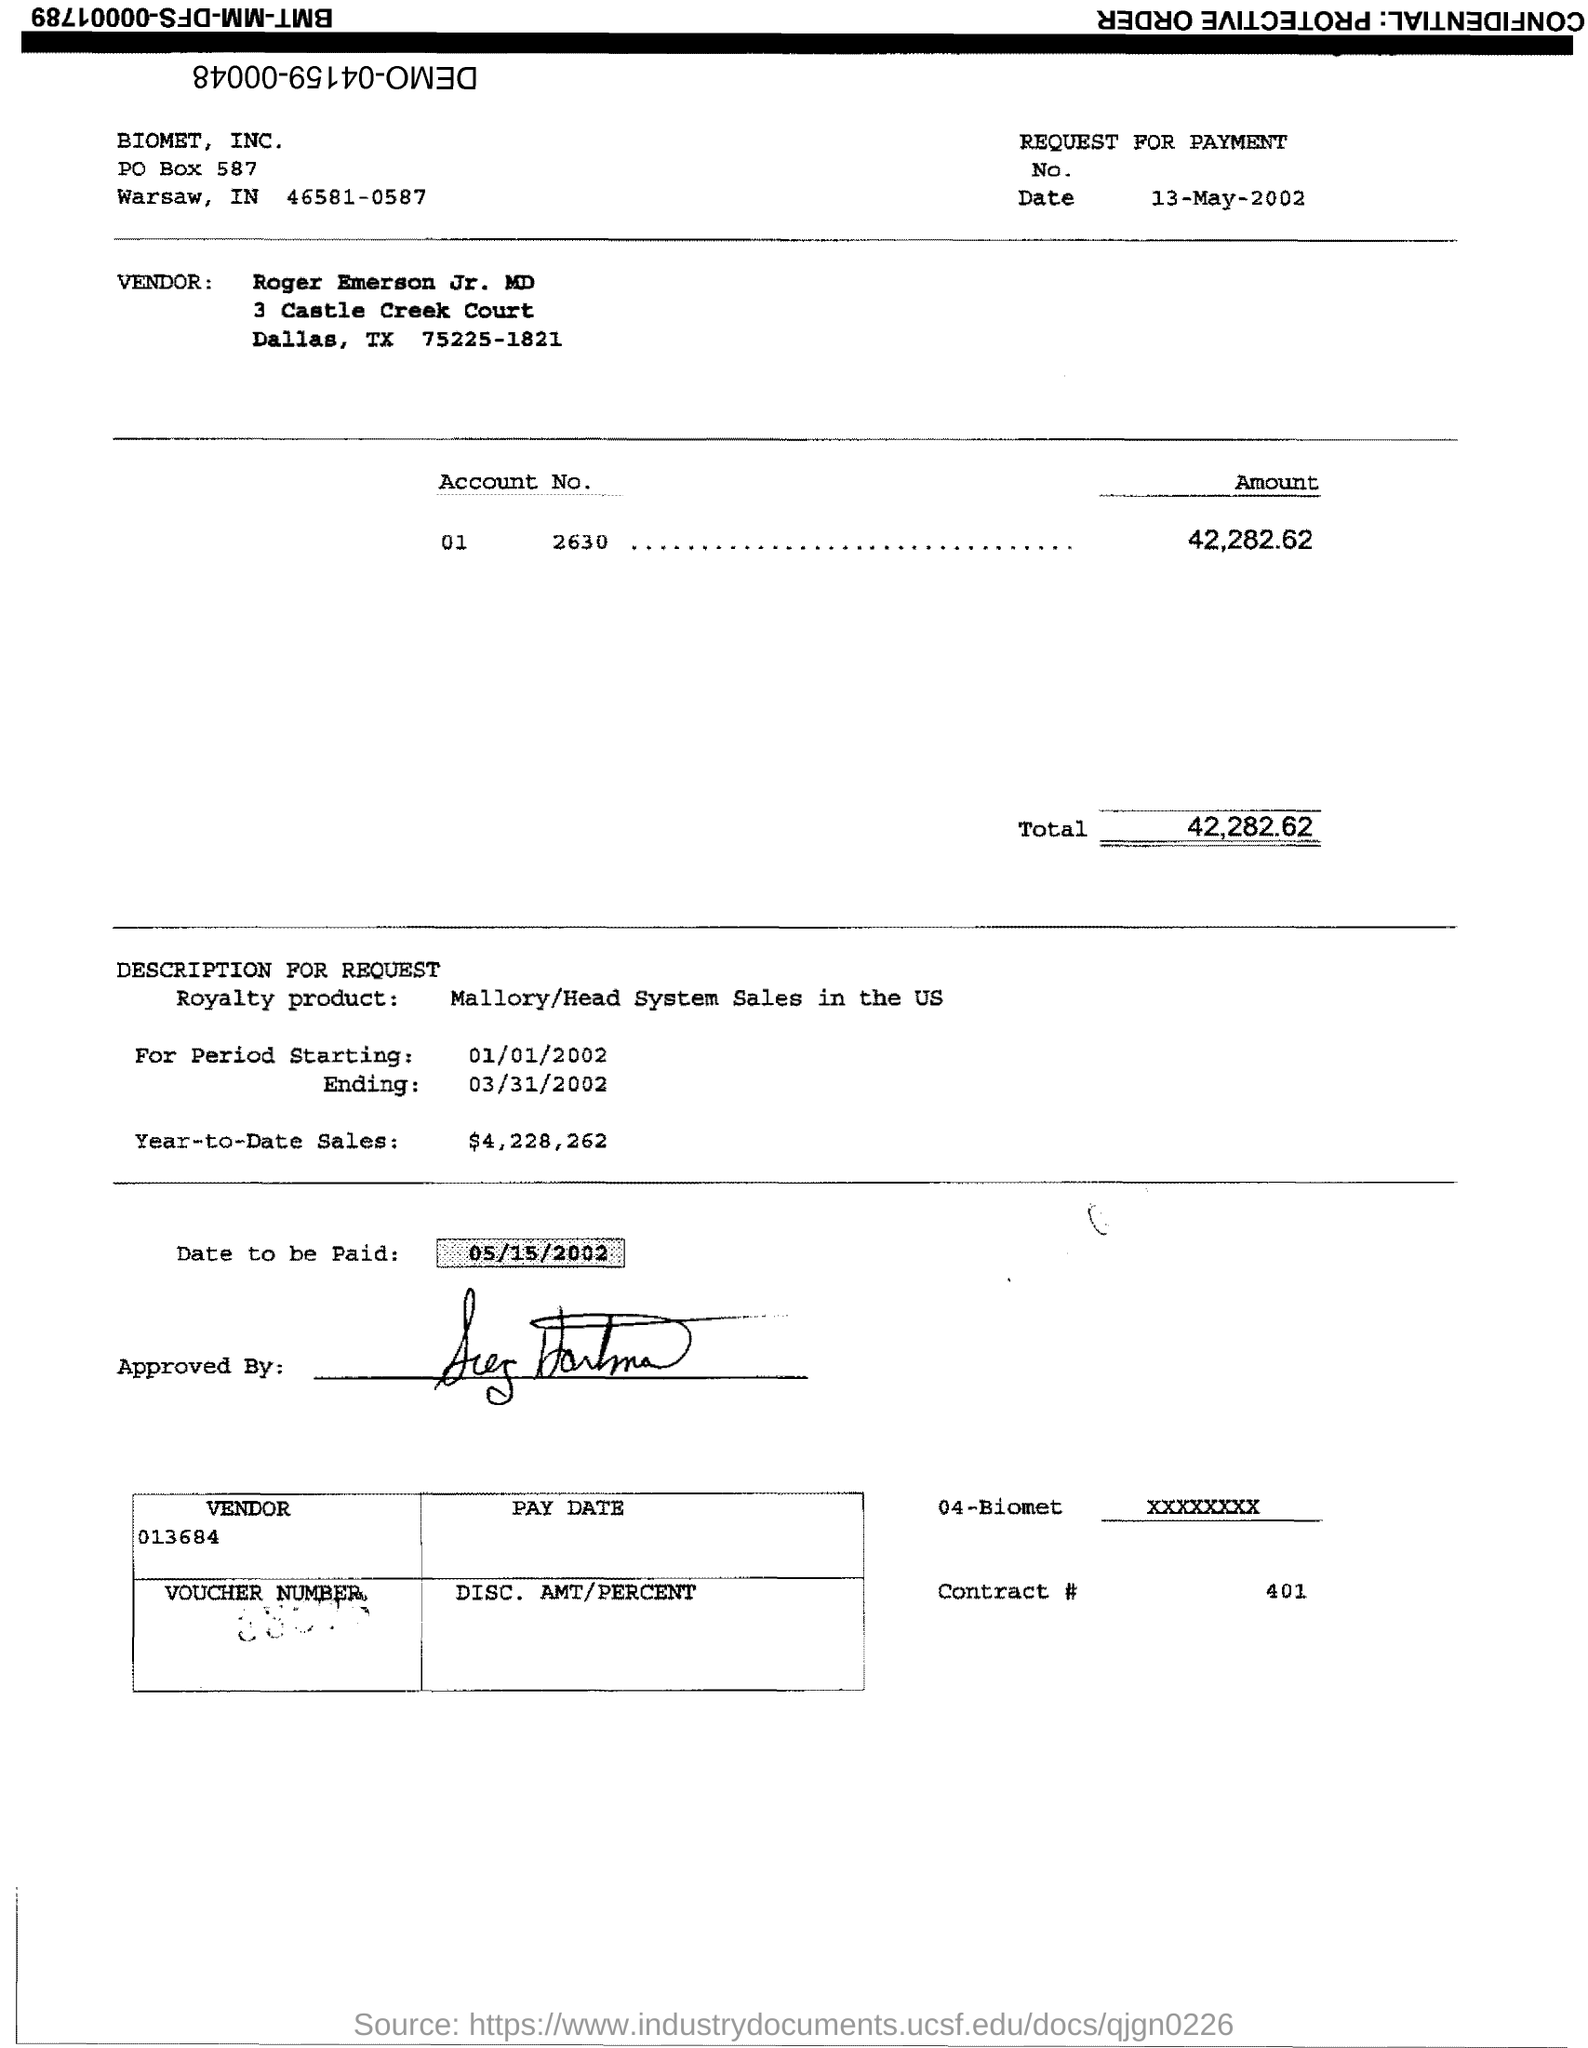What is the date indicated for the payment? According to the document, the date scheduled for the payment is May 15, 2002. 